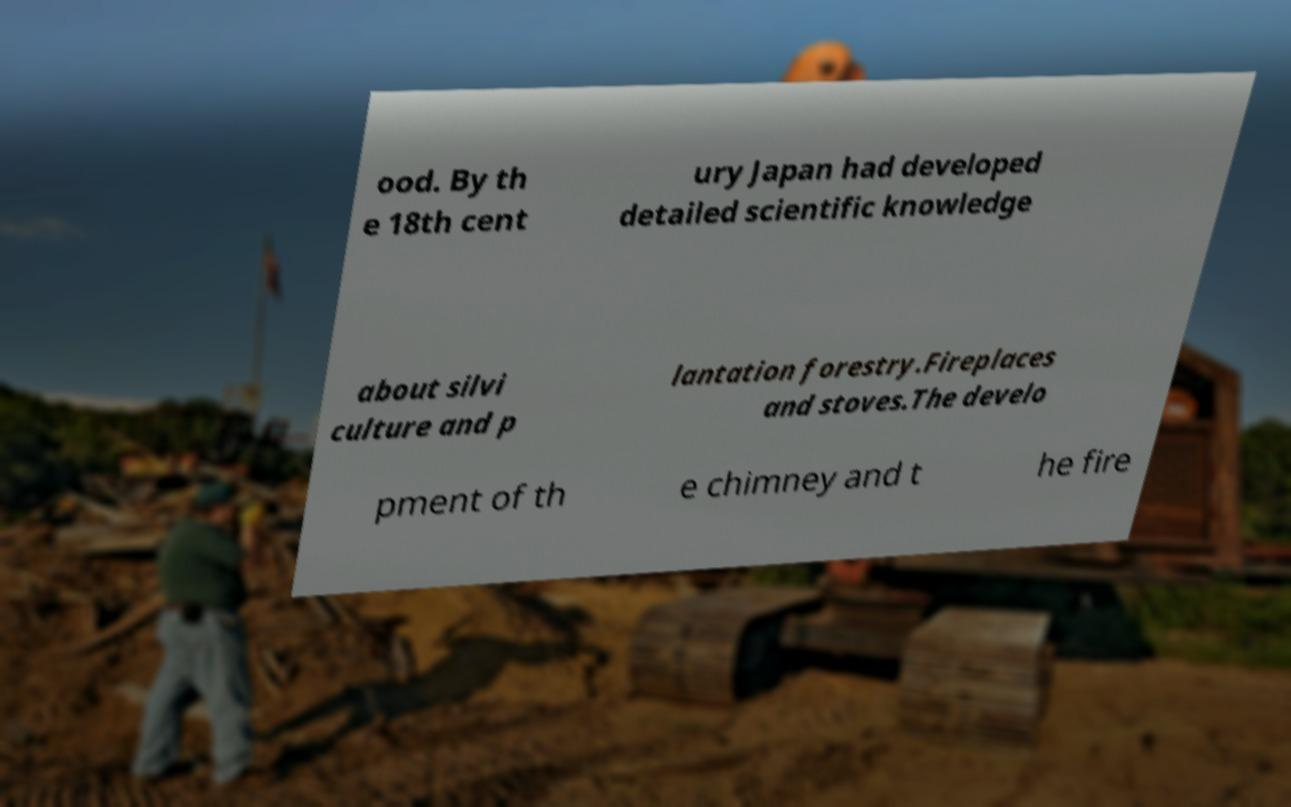There's text embedded in this image that I need extracted. Can you transcribe it verbatim? ood. By th e 18th cent ury Japan had developed detailed scientific knowledge about silvi culture and p lantation forestry.Fireplaces and stoves.The develo pment of th e chimney and t he fire 